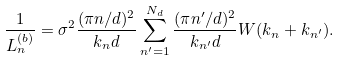<formula> <loc_0><loc_0><loc_500><loc_500>\frac { 1 } { L _ { n } ^ { ( b ) } } = \sigma ^ { 2 } \frac { ( \pi n / d ) ^ { 2 } } { k _ { n } d } \sum _ { n ^ { \prime } = 1 } ^ { N _ { d } } \frac { ( \pi n ^ { \prime } / d ) ^ { 2 } } { k _ { n ^ { \prime } } d } W ( k _ { n } + k _ { n ^ { \prime } } ) .</formula> 